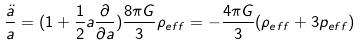<formula> <loc_0><loc_0><loc_500><loc_500>\frac { \ddot { a } } { a } = ( 1 + \frac { 1 } { 2 } a \frac { \partial } { \partial a } ) \frac { 8 \pi G } { 3 } \rho _ { e f f } = - \frac { 4 \pi G } { 3 } ( \rho _ { e f f } + 3 p _ { e f f } )</formula> 